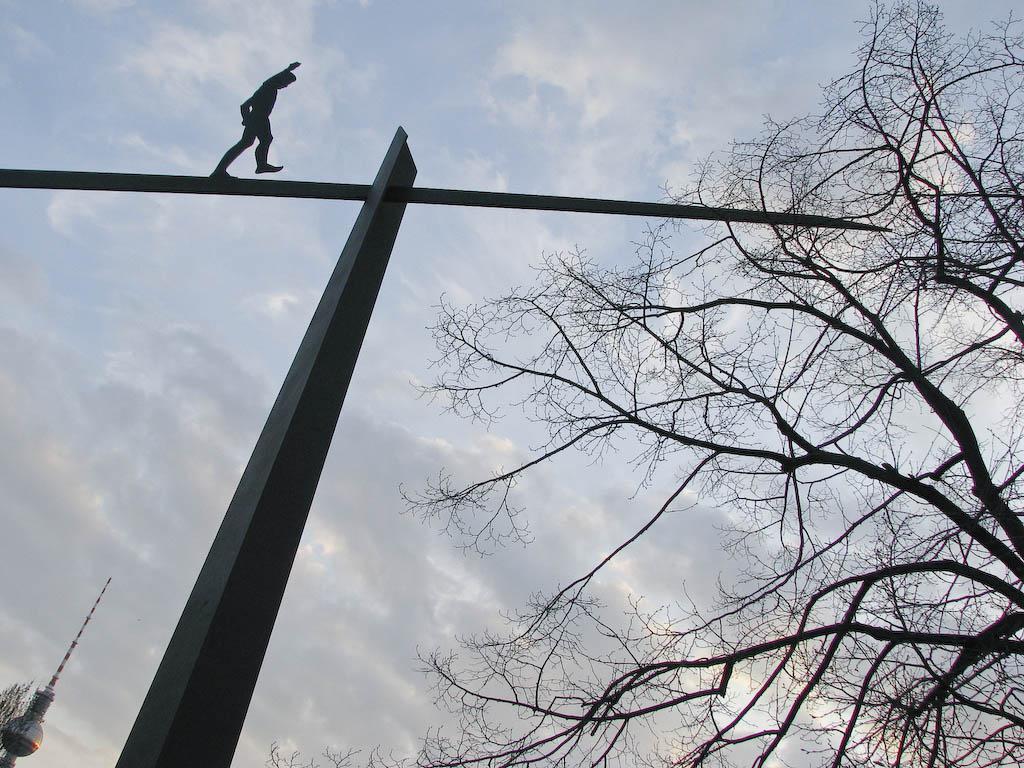In one or two sentences, can you explain what this image depicts? In this image there is a person walking on the metal structure, on the right side of the image there is a tree and on the left side of the image there is a structure. In the background there is the sky. 